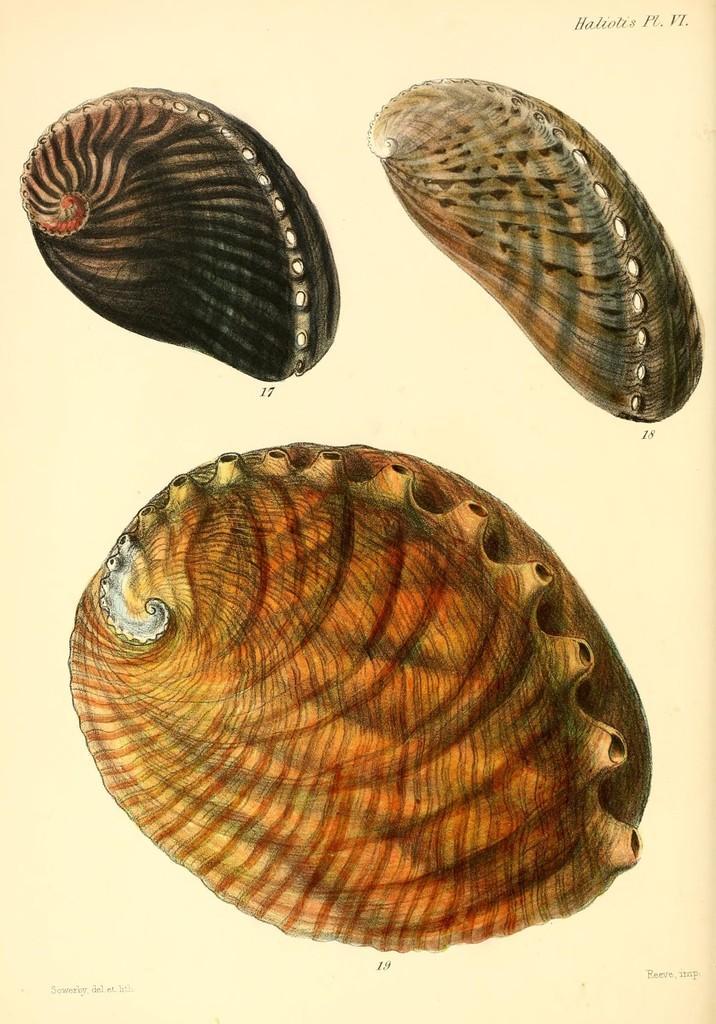Can you describe this image briefly? In this image, I can see words, numbers and the pictures of seashells on a paper. 